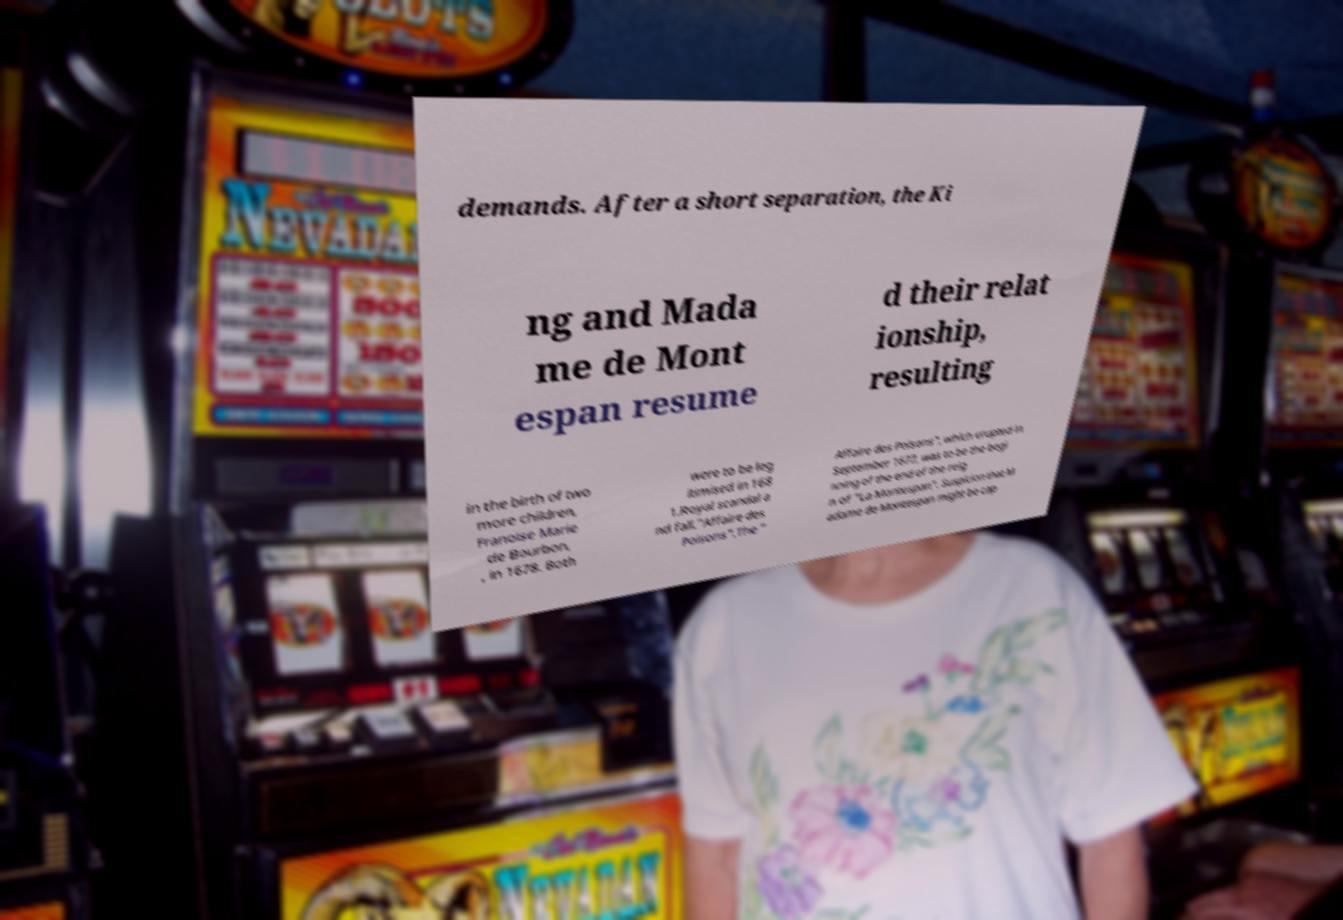I need the written content from this picture converted into text. Can you do that? demands. After a short separation, the Ki ng and Mada me de Mont espan resume d their relat ionship, resulting in the birth of two more children, Franoise Marie de Bourbon, , in 1678. Both were to be leg itimised in 168 1.Royal scandal a nd fall."Affaire des Poisons".The " Affaire des Poisons", which erupted in September 1677, was to be the begi nning of the end of the reig n of "La Montespan". Suspicion that M adame de Montespan might be cap 